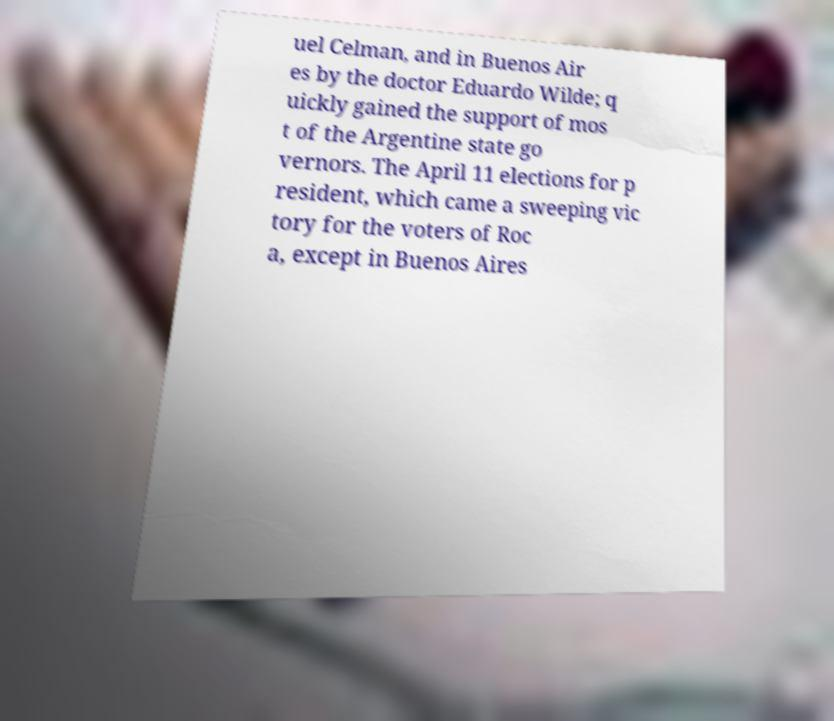Could you extract and type out the text from this image? uel Celman, and in Buenos Air es by the doctor Eduardo Wilde; q uickly gained the support of mos t of the Argentine state go vernors. The April 11 elections for p resident, which came a sweeping vic tory for the voters of Roc a, except in Buenos Aires 